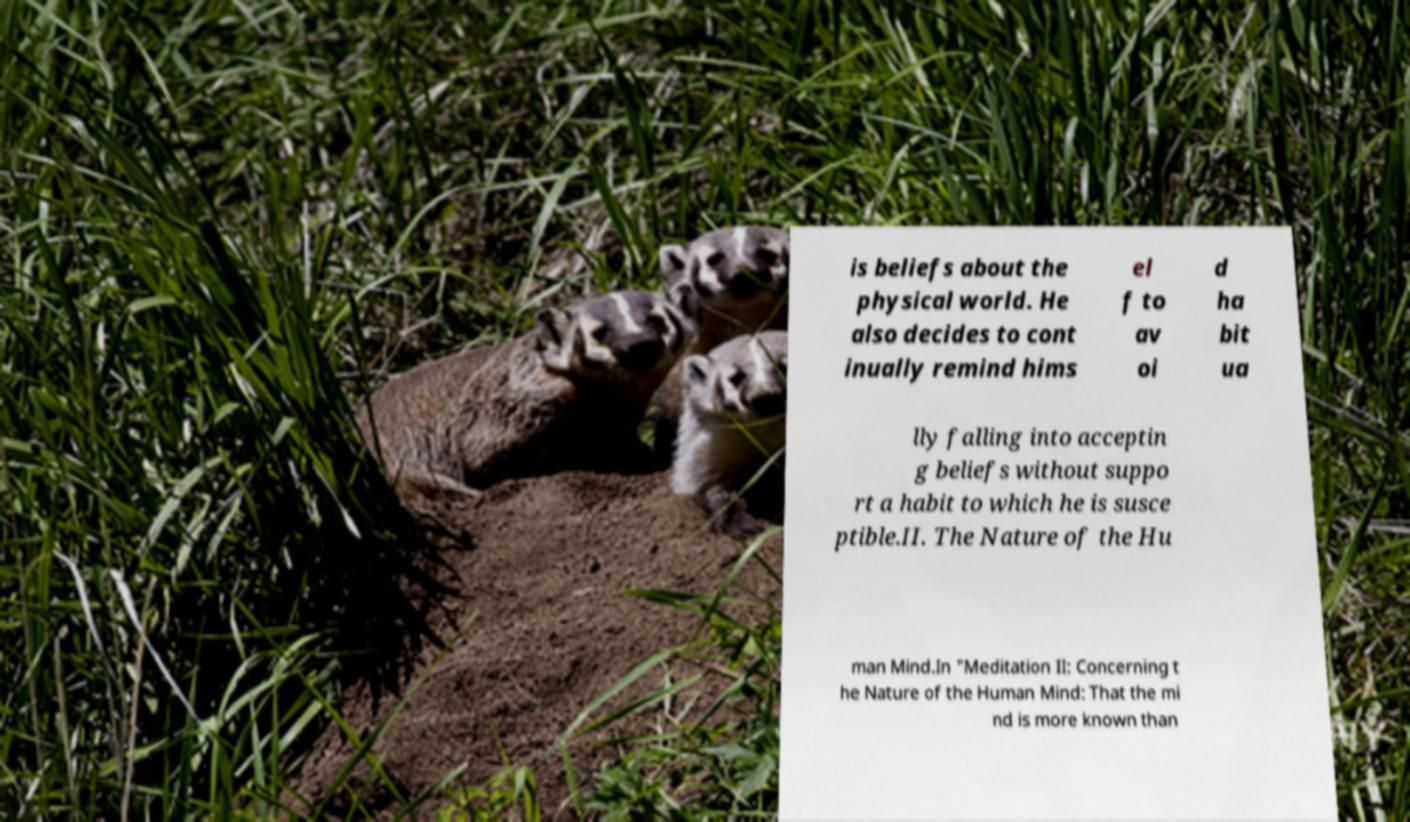There's text embedded in this image that I need extracted. Can you transcribe it verbatim? is beliefs about the physical world. He also decides to cont inually remind hims el f to av oi d ha bit ua lly falling into acceptin g beliefs without suppo rt a habit to which he is susce ptible.II. The Nature of the Hu man Mind.In "Meditation II: Concerning t he Nature of the Human Mind: That the mi nd is more known than 